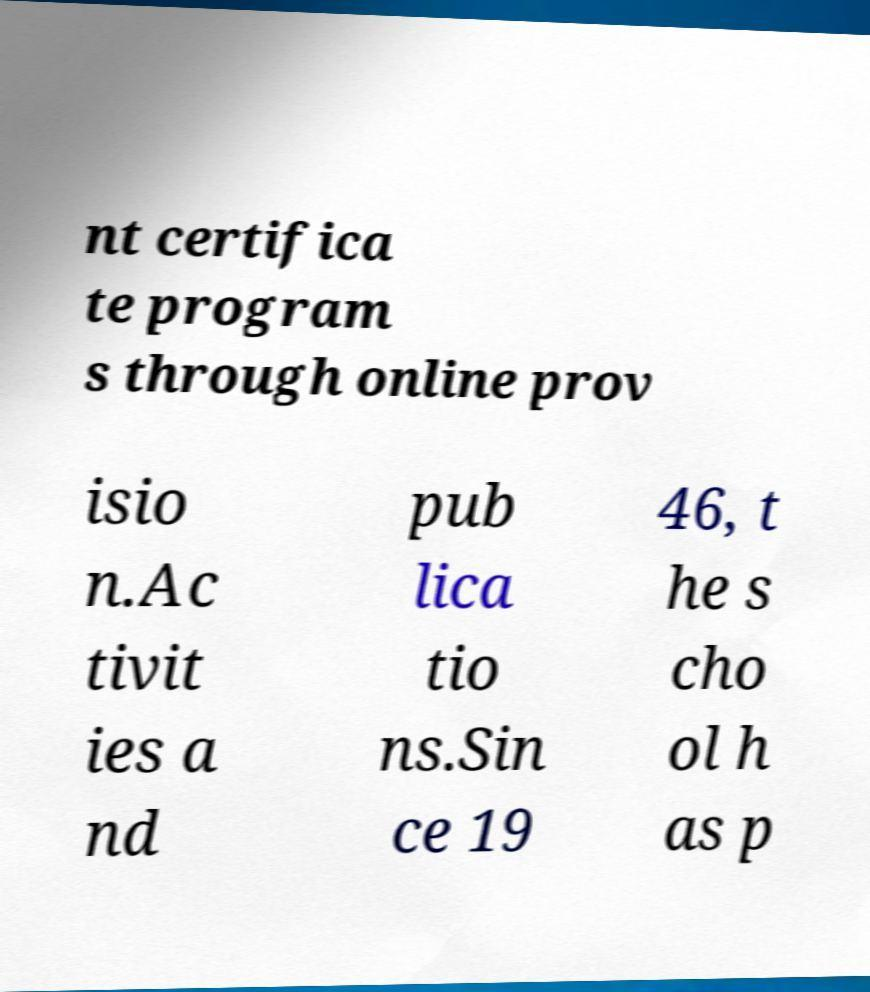Can you read and provide the text displayed in the image?This photo seems to have some interesting text. Can you extract and type it out for me? nt certifica te program s through online prov isio n.Ac tivit ies a nd pub lica tio ns.Sin ce 19 46, t he s cho ol h as p 